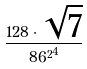<formula> <loc_0><loc_0><loc_500><loc_500>\frac { 1 2 8 \cdot \sqrt { 7 } } { { 8 6 ^ { 2 } } ^ { 4 } }</formula> 